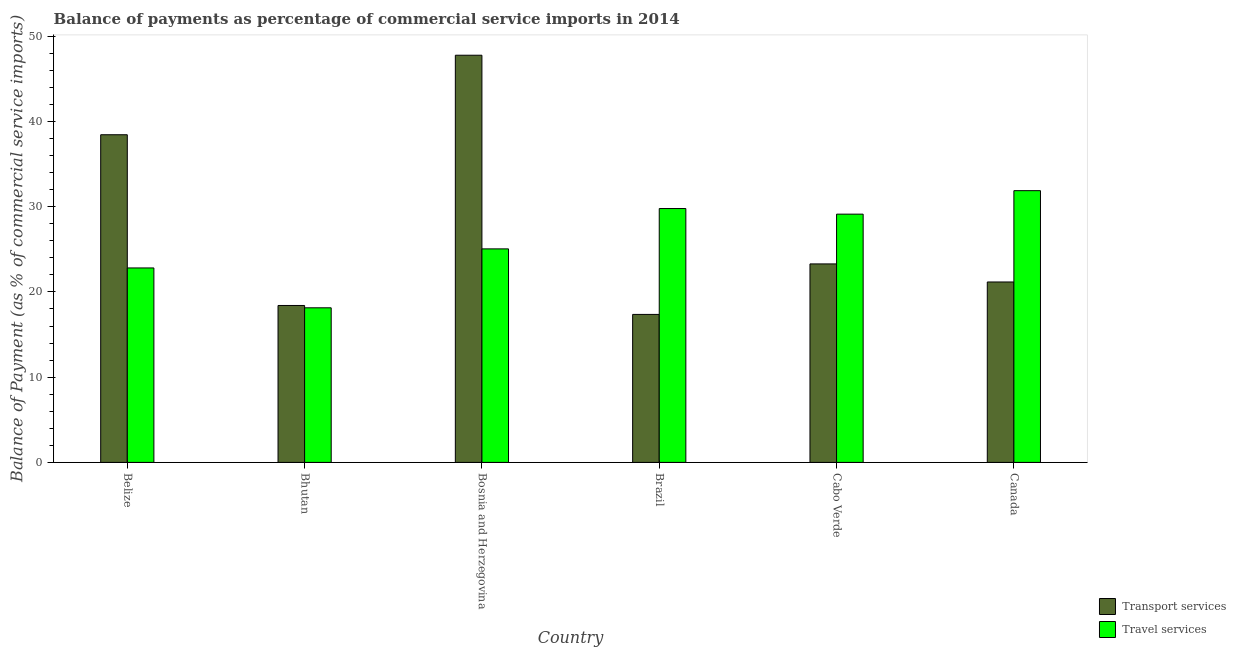How many groups of bars are there?
Make the answer very short. 6. Are the number of bars on each tick of the X-axis equal?
Ensure brevity in your answer.  Yes. How many bars are there on the 1st tick from the left?
Your answer should be compact. 2. How many bars are there on the 4th tick from the right?
Make the answer very short. 2. In how many cases, is the number of bars for a given country not equal to the number of legend labels?
Provide a short and direct response. 0. What is the balance of payments of travel services in Bhutan?
Keep it short and to the point. 18.14. Across all countries, what is the maximum balance of payments of transport services?
Offer a very short reply. 47.78. Across all countries, what is the minimum balance of payments of transport services?
Ensure brevity in your answer.  17.36. In which country was the balance of payments of transport services maximum?
Provide a short and direct response. Bosnia and Herzegovina. In which country was the balance of payments of transport services minimum?
Ensure brevity in your answer.  Brazil. What is the total balance of payments of travel services in the graph?
Ensure brevity in your answer.  156.81. What is the difference between the balance of payments of travel services in Belize and that in Brazil?
Offer a terse response. -6.97. What is the difference between the balance of payments of travel services in Brazil and the balance of payments of transport services in Bhutan?
Your answer should be very brief. 11.37. What is the average balance of payments of travel services per country?
Keep it short and to the point. 26.13. What is the difference between the balance of payments of travel services and balance of payments of transport services in Bhutan?
Offer a terse response. -0.27. In how many countries, is the balance of payments of transport services greater than 22 %?
Provide a succinct answer. 3. What is the ratio of the balance of payments of travel services in Brazil to that in Canada?
Provide a succinct answer. 0.93. Is the difference between the balance of payments of travel services in Bosnia and Herzegovina and Cabo Verde greater than the difference between the balance of payments of transport services in Bosnia and Herzegovina and Cabo Verde?
Offer a terse response. No. What is the difference between the highest and the second highest balance of payments of travel services?
Offer a terse response. 2.1. What is the difference between the highest and the lowest balance of payments of travel services?
Your response must be concise. 13.75. In how many countries, is the balance of payments of transport services greater than the average balance of payments of transport services taken over all countries?
Your response must be concise. 2. What does the 2nd bar from the left in Cabo Verde represents?
Your answer should be very brief. Travel services. What does the 2nd bar from the right in Canada represents?
Make the answer very short. Transport services. How many bars are there?
Ensure brevity in your answer.  12. Are all the bars in the graph horizontal?
Ensure brevity in your answer.  No. What is the difference between two consecutive major ticks on the Y-axis?
Your answer should be compact. 10. Are the values on the major ticks of Y-axis written in scientific E-notation?
Give a very brief answer. No. Where does the legend appear in the graph?
Your answer should be very brief. Bottom right. How many legend labels are there?
Provide a short and direct response. 2. How are the legend labels stacked?
Your answer should be compact. Vertical. What is the title of the graph?
Provide a succinct answer. Balance of payments as percentage of commercial service imports in 2014. Does "Total Population" appear as one of the legend labels in the graph?
Provide a short and direct response. No. What is the label or title of the Y-axis?
Make the answer very short. Balance of Payment (as % of commercial service imports). What is the Balance of Payment (as % of commercial service imports) in Transport services in Belize?
Offer a terse response. 38.45. What is the Balance of Payment (as % of commercial service imports) of Travel services in Belize?
Offer a very short reply. 22.82. What is the Balance of Payment (as % of commercial service imports) of Transport services in Bhutan?
Give a very brief answer. 18.41. What is the Balance of Payment (as % of commercial service imports) of Travel services in Bhutan?
Provide a succinct answer. 18.14. What is the Balance of Payment (as % of commercial service imports) in Transport services in Bosnia and Herzegovina?
Offer a very short reply. 47.78. What is the Balance of Payment (as % of commercial service imports) in Travel services in Bosnia and Herzegovina?
Provide a short and direct response. 25.05. What is the Balance of Payment (as % of commercial service imports) in Transport services in Brazil?
Provide a succinct answer. 17.36. What is the Balance of Payment (as % of commercial service imports) of Travel services in Brazil?
Your response must be concise. 29.79. What is the Balance of Payment (as % of commercial service imports) in Transport services in Cabo Verde?
Keep it short and to the point. 23.29. What is the Balance of Payment (as % of commercial service imports) in Travel services in Cabo Verde?
Your response must be concise. 29.13. What is the Balance of Payment (as % of commercial service imports) in Transport services in Canada?
Ensure brevity in your answer.  21.17. What is the Balance of Payment (as % of commercial service imports) of Travel services in Canada?
Offer a very short reply. 31.88. Across all countries, what is the maximum Balance of Payment (as % of commercial service imports) in Transport services?
Keep it short and to the point. 47.78. Across all countries, what is the maximum Balance of Payment (as % of commercial service imports) of Travel services?
Provide a short and direct response. 31.88. Across all countries, what is the minimum Balance of Payment (as % of commercial service imports) in Transport services?
Your answer should be very brief. 17.36. Across all countries, what is the minimum Balance of Payment (as % of commercial service imports) of Travel services?
Keep it short and to the point. 18.14. What is the total Balance of Payment (as % of commercial service imports) in Transport services in the graph?
Your answer should be very brief. 166.46. What is the total Balance of Payment (as % of commercial service imports) in Travel services in the graph?
Offer a terse response. 156.81. What is the difference between the Balance of Payment (as % of commercial service imports) of Transport services in Belize and that in Bhutan?
Your answer should be compact. 20.03. What is the difference between the Balance of Payment (as % of commercial service imports) in Travel services in Belize and that in Bhutan?
Ensure brevity in your answer.  4.68. What is the difference between the Balance of Payment (as % of commercial service imports) in Transport services in Belize and that in Bosnia and Herzegovina?
Your answer should be very brief. -9.33. What is the difference between the Balance of Payment (as % of commercial service imports) of Travel services in Belize and that in Bosnia and Herzegovina?
Your answer should be very brief. -2.24. What is the difference between the Balance of Payment (as % of commercial service imports) of Transport services in Belize and that in Brazil?
Offer a very short reply. 21.08. What is the difference between the Balance of Payment (as % of commercial service imports) in Travel services in Belize and that in Brazil?
Your answer should be very brief. -6.97. What is the difference between the Balance of Payment (as % of commercial service imports) in Transport services in Belize and that in Cabo Verde?
Provide a short and direct response. 15.16. What is the difference between the Balance of Payment (as % of commercial service imports) of Travel services in Belize and that in Cabo Verde?
Your response must be concise. -6.31. What is the difference between the Balance of Payment (as % of commercial service imports) of Transport services in Belize and that in Canada?
Ensure brevity in your answer.  17.28. What is the difference between the Balance of Payment (as % of commercial service imports) of Travel services in Belize and that in Canada?
Your response must be concise. -9.07. What is the difference between the Balance of Payment (as % of commercial service imports) of Transport services in Bhutan and that in Bosnia and Herzegovina?
Your answer should be very brief. -29.36. What is the difference between the Balance of Payment (as % of commercial service imports) in Travel services in Bhutan and that in Bosnia and Herzegovina?
Provide a short and direct response. -6.91. What is the difference between the Balance of Payment (as % of commercial service imports) of Transport services in Bhutan and that in Brazil?
Give a very brief answer. 1.05. What is the difference between the Balance of Payment (as % of commercial service imports) of Travel services in Bhutan and that in Brazil?
Keep it short and to the point. -11.65. What is the difference between the Balance of Payment (as % of commercial service imports) in Transport services in Bhutan and that in Cabo Verde?
Ensure brevity in your answer.  -4.88. What is the difference between the Balance of Payment (as % of commercial service imports) in Travel services in Bhutan and that in Cabo Verde?
Ensure brevity in your answer.  -10.99. What is the difference between the Balance of Payment (as % of commercial service imports) of Transport services in Bhutan and that in Canada?
Your response must be concise. -2.76. What is the difference between the Balance of Payment (as % of commercial service imports) in Travel services in Bhutan and that in Canada?
Your answer should be compact. -13.75. What is the difference between the Balance of Payment (as % of commercial service imports) of Transport services in Bosnia and Herzegovina and that in Brazil?
Your answer should be compact. 30.41. What is the difference between the Balance of Payment (as % of commercial service imports) of Travel services in Bosnia and Herzegovina and that in Brazil?
Keep it short and to the point. -4.73. What is the difference between the Balance of Payment (as % of commercial service imports) in Transport services in Bosnia and Herzegovina and that in Cabo Verde?
Provide a short and direct response. 24.49. What is the difference between the Balance of Payment (as % of commercial service imports) in Travel services in Bosnia and Herzegovina and that in Cabo Verde?
Keep it short and to the point. -4.08. What is the difference between the Balance of Payment (as % of commercial service imports) of Transport services in Bosnia and Herzegovina and that in Canada?
Give a very brief answer. 26.61. What is the difference between the Balance of Payment (as % of commercial service imports) in Travel services in Bosnia and Herzegovina and that in Canada?
Provide a short and direct response. -6.83. What is the difference between the Balance of Payment (as % of commercial service imports) in Transport services in Brazil and that in Cabo Verde?
Provide a succinct answer. -5.93. What is the difference between the Balance of Payment (as % of commercial service imports) of Travel services in Brazil and that in Cabo Verde?
Your response must be concise. 0.66. What is the difference between the Balance of Payment (as % of commercial service imports) of Transport services in Brazil and that in Canada?
Keep it short and to the point. -3.81. What is the difference between the Balance of Payment (as % of commercial service imports) of Travel services in Brazil and that in Canada?
Ensure brevity in your answer.  -2.1. What is the difference between the Balance of Payment (as % of commercial service imports) in Transport services in Cabo Verde and that in Canada?
Offer a terse response. 2.12. What is the difference between the Balance of Payment (as % of commercial service imports) of Travel services in Cabo Verde and that in Canada?
Offer a terse response. -2.75. What is the difference between the Balance of Payment (as % of commercial service imports) of Transport services in Belize and the Balance of Payment (as % of commercial service imports) of Travel services in Bhutan?
Give a very brief answer. 20.31. What is the difference between the Balance of Payment (as % of commercial service imports) in Transport services in Belize and the Balance of Payment (as % of commercial service imports) in Travel services in Bosnia and Herzegovina?
Your answer should be very brief. 13.39. What is the difference between the Balance of Payment (as % of commercial service imports) of Transport services in Belize and the Balance of Payment (as % of commercial service imports) of Travel services in Brazil?
Keep it short and to the point. 8.66. What is the difference between the Balance of Payment (as % of commercial service imports) of Transport services in Belize and the Balance of Payment (as % of commercial service imports) of Travel services in Cabo Verde?
Offer a very short reply. 9.32. What is the difference between the Balance of Payment (as % of commercial service imports) in Transport services in Belize and the Balance of Payment (as % of commercial service imports) in Travel services in Canada?
Your answer should be very brief. 6.56. What is the difference between the Balance of Payment (as % of commercial service imports) in Transport services in Bhutan and the Balance of Payment (as % of commercial service imports) in Travel services in Bosnia and Herzegovina?
Provide a short and direct response. -6.64. What is the difference between the Balance of Payment (as % of commercial service imports) of Transport services in Bhutan and the Balance of Payment (as % of commercial service imports) of Travel services in Brazil?
Your answer should be very brief. -11.37. What is the difference between the Balance of Payment (as % of commercial service imports) of Transport services in Bhutan and the Balance of Payment (as % of commercial service imports) of Travel services in Cabo Verde?
Offer a terse response. -10.72. What is the difference between the Balance of Payment (as % of commercial service imports) in Transport services in Bhutan and the Balance of Payment (as % of commercial service imports) in Travel services in Canada?
Make the answer very short. -13.47. What is the difference between the Balance of Payment (as % of commercial service imports) in Transport services in Bosnia and Herzegovina and the Balance of Payment (as % of commercial service imports) in Travel services in Brazil?
Offer a terse response. 17.99. What is the difference between the Balance of Payment (as % of commercial service imports) of Transport services in Bosnia and Herzegovina and the Balance of Payment (as % of commercial service imports) of Travel services in Cabo Verde?
Provide a short and direct response. 18.65. What is the difference between the Balance of Payment (as % of commercial service imports) of Transport services in Bosnia and Herzegovina and the Balance of Payment (as % of commercial service imports) of Travel services in Canada?
Offer a very short reply. 15.89. What is the difference between the Balance of Payment (as % of commercial service imports) of Transport services in Brazil and the Balance of Payment (as % of commercial service imports) of Travel services in Cabo Verde?
Ensure brevity in your answer.  -11.77. What is the difference between the Balance of Payment (as % of commercial service imports) of Transport services in Brazil and the Balance of Payment (as % of commercial service imports) of Travel services in Canada?
Your response must be concise. -14.52. What is the difference between the Balance of Payment (as % of commercial service imports) of Transport services in Cabo Verde and the Balance of Payment (as % of commercial service imports) of Travel services in Canada?
Give a very brief answer. -8.59. What is the average Balance of Payment (as % of commercial service imports) in Transport services per country?
Provide a succinct answer. 27.74. What is the average Balance of Payment (as % of commercial service imports) of Travel services per country?
Give a very brief answer. 26.13. What is the difference between the Balance of Payment (as % of commercial service imports) in Transport services and Balance of Payment (as % of commercial service imports) in Travel services in Belize?
Your answer should be very brief. 15.63. What is the difference between the Balance of Payment (as % of commercial service imports) in Transport services and Balance of Payment (as % of commercial service imports) in Travel services in Bhutan?
Your answer should be very brief. 0.27. What is the difference between the Balance of Payment (as % of commercial service imports) of Transport services and Balance of Payment (as % of commercial service imports) of Travel services in Bosnia and Herzegovina?
Keep it short and to the point. 22.72. What is the difference between the Balance of Payment (as % of commercial service imports) of Transport services and Balance of Payment (as % of commercial service imports) of Travel services in Brazil?
Ensure brevity in your answer.  -12.42. What is the difference between the Balance of Payment (as % of commercial service imports) of Transport services and Balance of Payment (as % of commercial service imports) of Travel services in Cabo Verde?
Offer a terse response. -5.84. What is the difference between the Balance of Payment (as % of commercial service imports) of Transport services and Balance of Payment (as % of commercial service imports) of Travel services in Canada?
Your response must be concise. -10.71. What is the ratio of the Balance of Payment (as % of commercial service imports) of Transport services in Belize to that in Bhutan?
Your answer should be very brief. 2.09. What is the ratio of the Balance of Payment (as % of commercial service imports) of Travel services in Belize to that in Bhutan?
Your response must be concise. 1.26. What is the ratio of the Balance of Payment (as % of commercial service imports) of Transport services in Belize to that in Bosnia and Herzegovina?
Offer a very short reply. 0.8. What is the ratio of the Balance of Payment (as % of commercial service imports) of Travel services in Belize to that in Bosnia and Herzegovina?
Your answer should be very brief. 0.91. What is the ratio of the Balance of Payment (as % of commercial service imports) in Transport services in Belize to that in Brazil?
Make the answer very short. 2.21. What is the ratio of the Balance of Payment (as % of commercial service imports) in Travel services in Belize to that in Brazil?
Ensure brevity in your answer.  0.77. What is the ratio of the Balance of Payment (as % of commercial service imports) in Transport services in Belize to that in Cabo Verde?
Your answer should be compact. 1.65. What is the ratio of the Balance of Payment (as % of commercial service imports) of Travel services in Belize to that in Cabo Verde?
Offer a very short reply. 0.78. What is the ratio of the Balance of Payment (as % of commercial service imports) in Transport services in Belize to that in Canada?
Offer a very short reply. 1.82. What is the ratio of the Balance of Payment (as % of commercial service imports) in Travel services in Belize to that in Canada?
Your response must be concise. 0.72. What is the ratio of the Balance of Payment (as % of commercial service imports) in Transport services in Bhutan to that in Bosnia and Herzegovina?
Provide a short and direct response. 0.39. What is the ratio of the Balance of Payment (as % of commercial service imports) of Travel services in Bhutan to that in Bosnia and Herzegovina?
Provide a short and direct response. 0.72. What is the ratio of the Balance of Payment (as % of commercial service imports) in Transport services in Bhutan to that in Brazil?
Your answer should be compact. 1.06. What is the ratio of the Balance of Payment (as % of commercial service imports) in Travel services in Bhutan to that in Brazil?
Your answer should be compact. 0.61. What is the ratio of the Balance of Payment (as % of commercial service imports) of Transport services in Bhutan to that in Cabo Verde?
Keep it short and to the point. 0.79. What is the ratio of the Balance of Payment (as % of commercial service imports) in Travel services in Bhutan to that in Cabo Verde?
Your answer should be compact. 0.62. What is the ratio of the Balance of Payment (as % of commercial service imports) in Transport services in Bhutan to that in Canada?
Offer a terse response. 0.87. What is the ratio of the Balance of Payment (as % of commercial service imports) of Travel services in Bhutan to that in Canada?
Your answer should be very brief. 0.57. What is the ratio of the Balance of Payment (as % of commercial service imports) in Transport services in Bosnia and Herzegovina to that in Brazil?
Your answer should be compact. 2.75. What is the ratio of the Balance of Payment (as % of commercial service imports) of Travel services in Bosnia and Herzegovina to that in Brazil?
Your response must be concise. 0.84. What is the ratio of the Balance of Payment (as % of commercial service imports) in Transport services in Bosnia and Herzegovina to that in Cabo Verde?
Offer a terse response. 2.05. What is the ratio of the Balance of Payment (as % of commercial service imports) of Travel services in Bosnia and Herzegovina to that in Cabo Verde?
Your answer should be very brief. 0.86. What is the ratio of the Balance of Payment (as % of commercial service imports) of Transport services in Bosnia and Herzegovina to that in Canada?
Provide a short and direct response. 2.26. What is the ratio of the Balance of Payment (as % of commercial service imports) in Travel services in Bosnia and Herzegovina to that in Canada?
Offer a terse response. 0.79. What is the ratio of the Balance of Payment (as % of commercial service imports) of Transport services in Brazil to that in Cabo Verde?
Offer a terse response. 0.75. What is the ratio of the Balance of Payment (as % of commercial service imports) in Travel services in Brazil to that in Cabo Verde?
Your response must be concise. 1.02. What is the ratio of the Balance of Payment (as % of commercial service imports) in Transport services in Brazil to that in Canada?
Your answer should be compact. 0.82. What is the ratio of the Balance of Payment (as % of commercial service imports) in Travel services in Brazil to that in Canada?
Provide a succinct answer. 0.93. What is the ratio of the Balance of Payment (as % of commercial service imports) of Transport services in Cabo Verde to that in Canada?
Make the answer very short. 1.1. What is the ratio of the Balance of Payment (as % of commercial service imports) of Travel services in Cabo Verde to that in Canada?
Your response must be concise. 0.91. What is the difference between the highest and the second highest Balance of Payment (as % of commercial service imports) in Transport services?
Provide a succinct answer. 9.33. What is the difference between the highest and the second highest Balance of Payment (as % of commercial service imports) in Travel services?
Give a very brief answer. 2.1. What is the difference between the highest and the lowest Balance of Payment (as % of commercial service imports) of Transport services?
Ensure brevity in your answer.  30.41. What is the difference between the highest and the lowest Balance of Payment (as % of commercial service imports) in Travel services?
Make the answer very short. 13.75. 